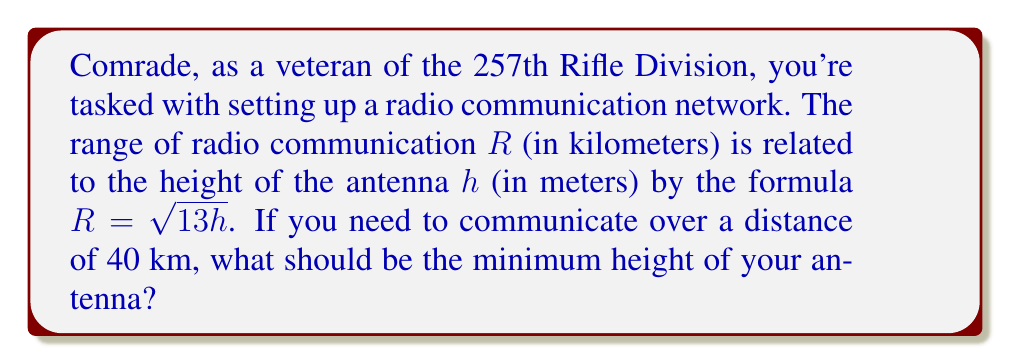Could you help me with this problem? Let's approach this step-by-step:

1) We are given the formula: $R = \sqrt{13h}$, where $R$ is the range in kilometers and $h$ is the height in meters.

2) We need to find $h$ when $R = 40$ km.

3) Let's substitute $R = 40$ into the formula:
   
   $40 = \sqrt{13h}$

4) To solve for $h$, we need to square both sides:
   
   $40^2 = 13h$

5) Simplify:
   
   $1600 = 13h$

6) Divide both sides by 13:
   
   $\frac{1600}{13} = h$

7) Calculate:
   
   $h \approx 123.0769$ meters

8) Since we're looking for the minimum height and we're dealing with physical measurements, we should round up to the nearest meter.
Answer: The minimum height of the antenna should be 124 meters. 